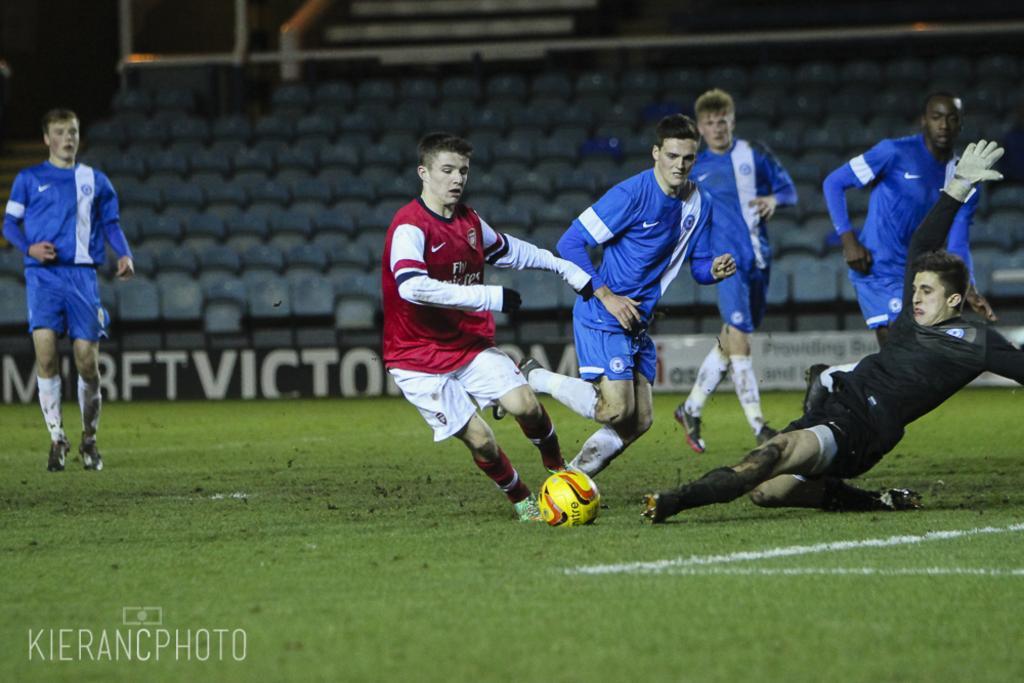Could you give a brief overview of what you see in this image? In this image there are group of people playing a football. There is a ball in the stadium. At the back side there are chairs. 